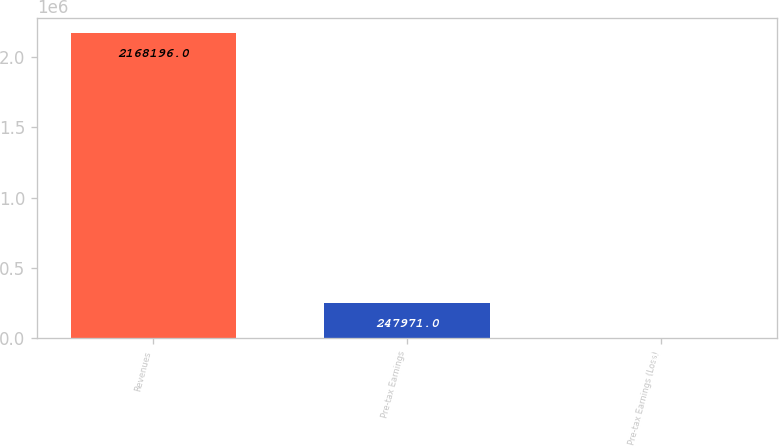Convert chart to OTSL. <chart><loc_0><loc_0><loc_500><loc_500><bar_chart><fcel>Revenues<fcel>Pre-tax Earnings<fcel>Pre-tax Earnings (Loss)<nl><fcel>2.1682e+06<fcel>247971<fcel>2324<nl></chart> 